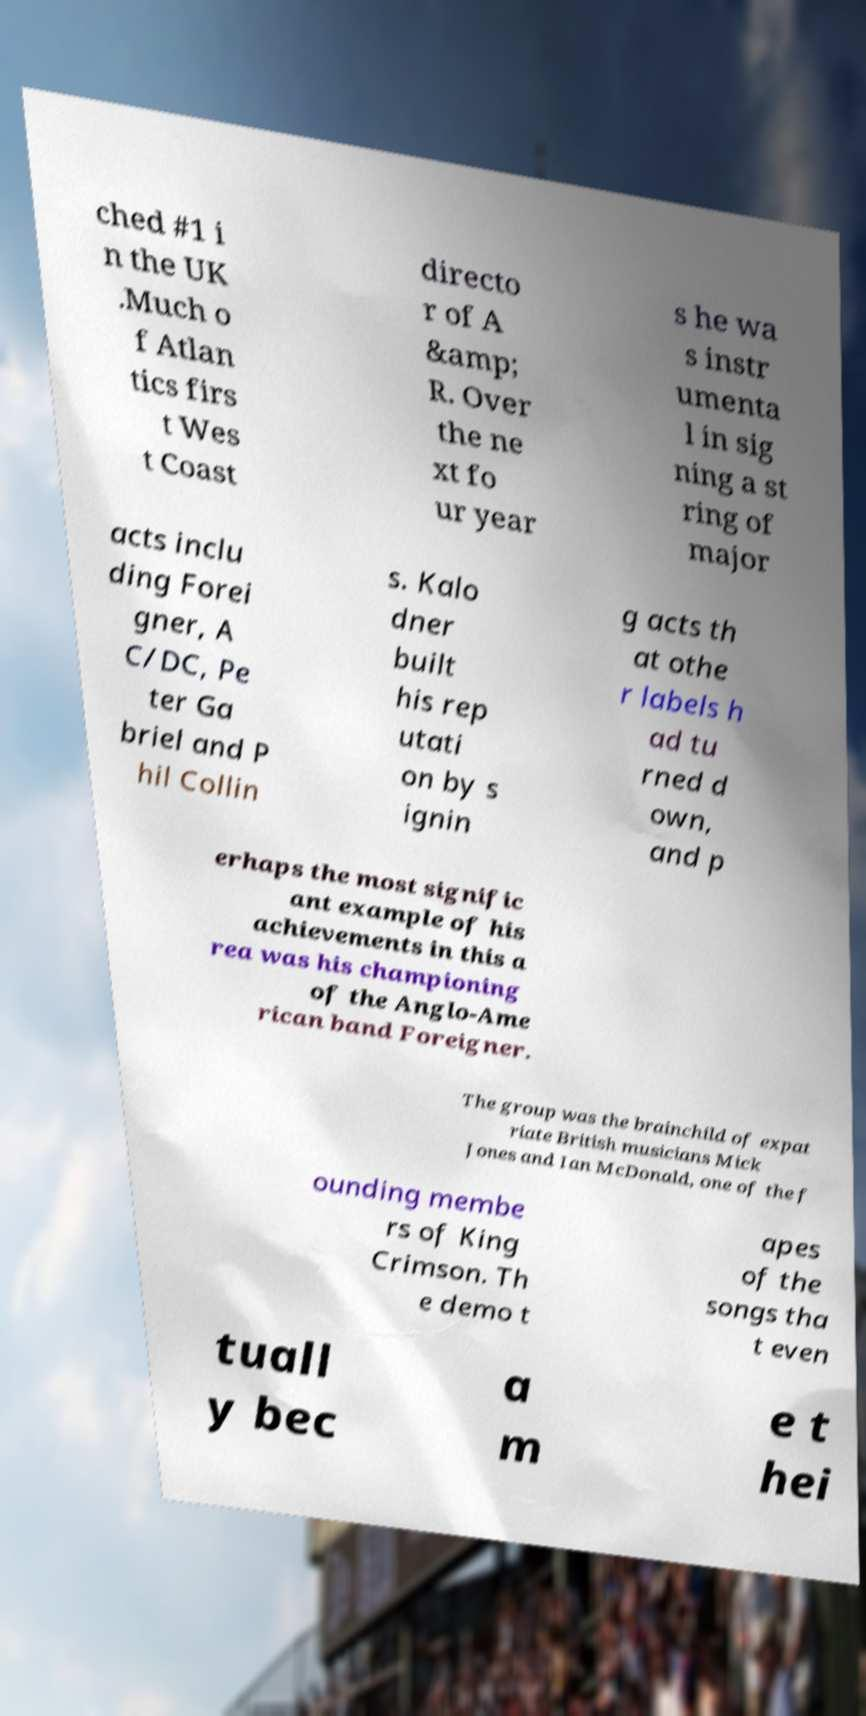Can you accurately transcribe the text from the provided image for me? ched #1 i n the UK .Much o f Atlan tics firs t Wes t Coast directo r of A &amp; R. Over the ne xt fo ur year s he wa s instr umenta l in sig ning a st ring of major acts inclu ding Forei gner, A C/DC, Pe ter Ga briel and P hil Collin s. Kalo dner built his rep utati on by s ignin g acts th at othe r labels h ad tu rned d own, and p erhaps the most signific ant example of his achievements in this a rea was his championing of the Anglo-Ame rican band Foreigner. The group was the brainchild of expat riate British musicians Mick Jones and Ian McDonald, one of the f ounding membe rs of King Crimson. Th e demo t apes of the songs tha t even tuall y bec a m e t hei 